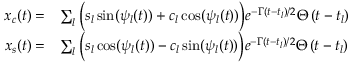Convert formula to latex. <formula><loc_0><loc_0><loc_500><loc_500>\begin{array} { r l } { x _ { c } ( t ) = } & { \sum _ { l } \left ( s _ { l } \sin ( \psi _ { l } ( t ) ) + c _ { l } \cos ( \psi _ { l } ( t ) ) \right ) e ^ { - \Gamma \left ( t - t _ { l } \right ) / 2 } \Theta \left ( t - t _ { l } \right ) } \\ { x _ { s } ( t ) = } & { \sum _ { l } \left ( s _ { l } \cos ( \psi _ { l } ( t ) ) - c _ { l } \sin ( \psi _ { l } ( t ) ) \right ) e ^ { - \Gamma \left ( t - t _ { l } \right ) / 2 } \Theta \left ( t - t _ { l } \right ) } \end{array}</formula> 